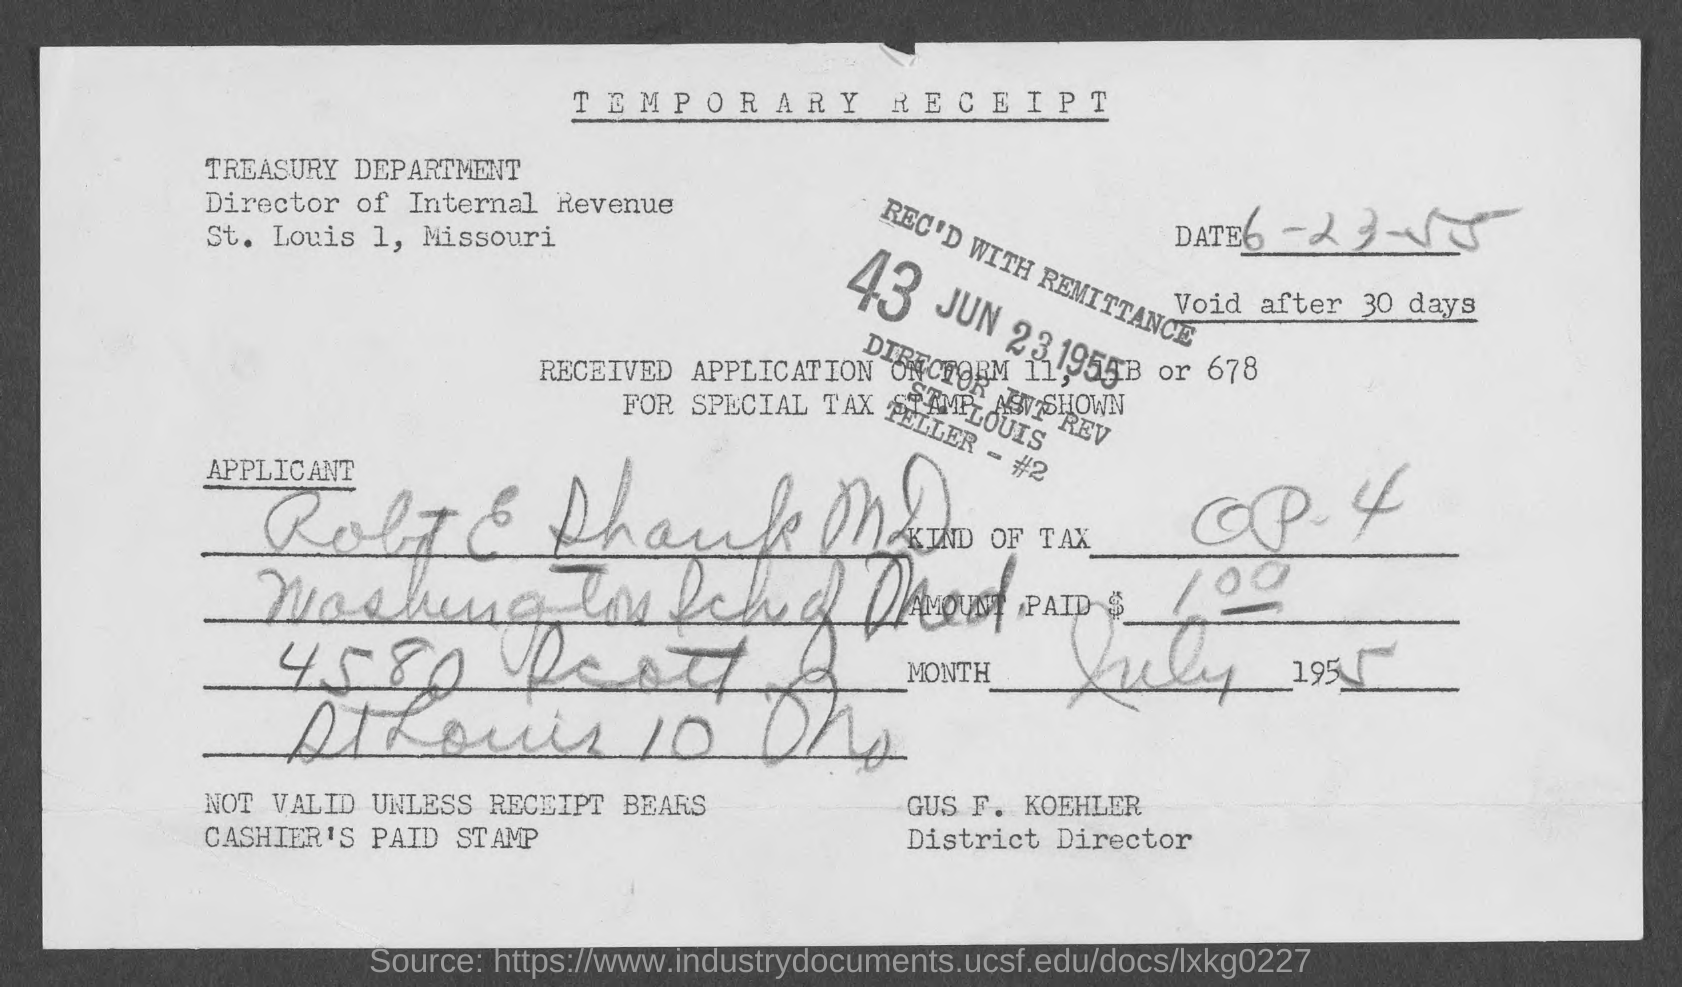Identify some key points in this picture. The temporary receipt is named Temporary Receipt. Gus F. Koehler is the District Director. 